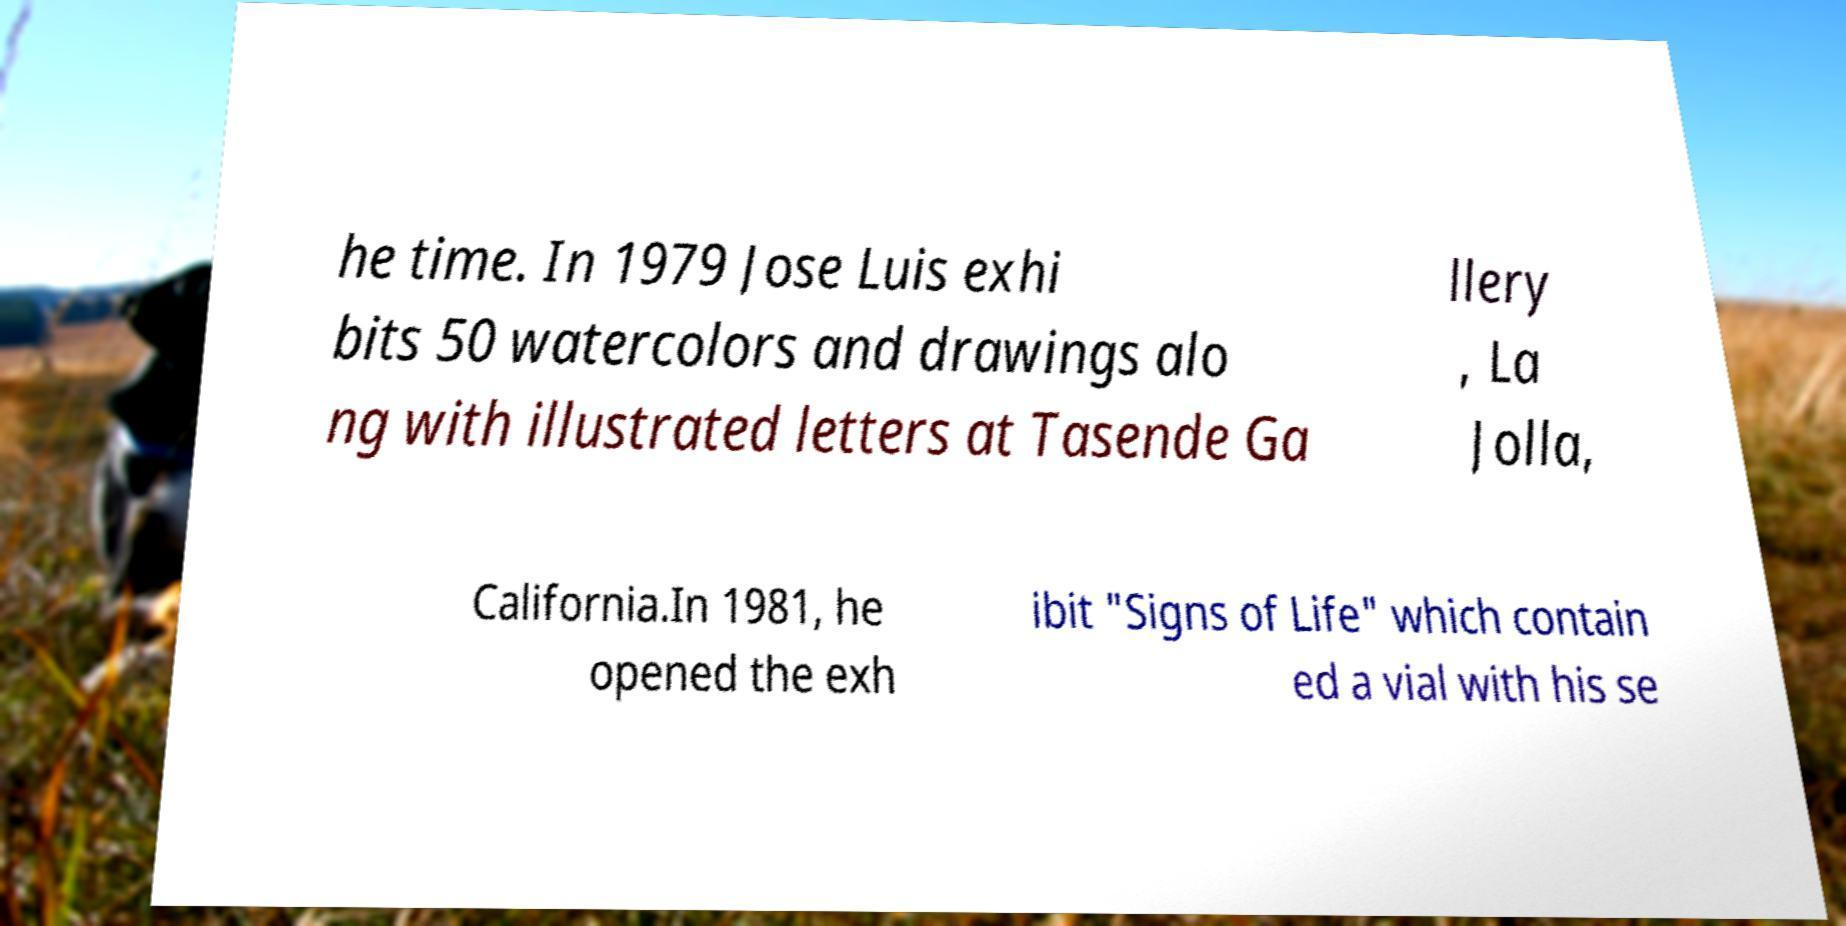What messages or text are displayed in this image? I need them in a readable, typed format. he time. In 1979 Jose Luis exhi bits 50 watercolors and drawings alo ng with illustrated letters at Tasende Ga llery , La Jolla, California.In 1981, he opened the exh ibit "Signs of Life" which contain ed a vial with his se 